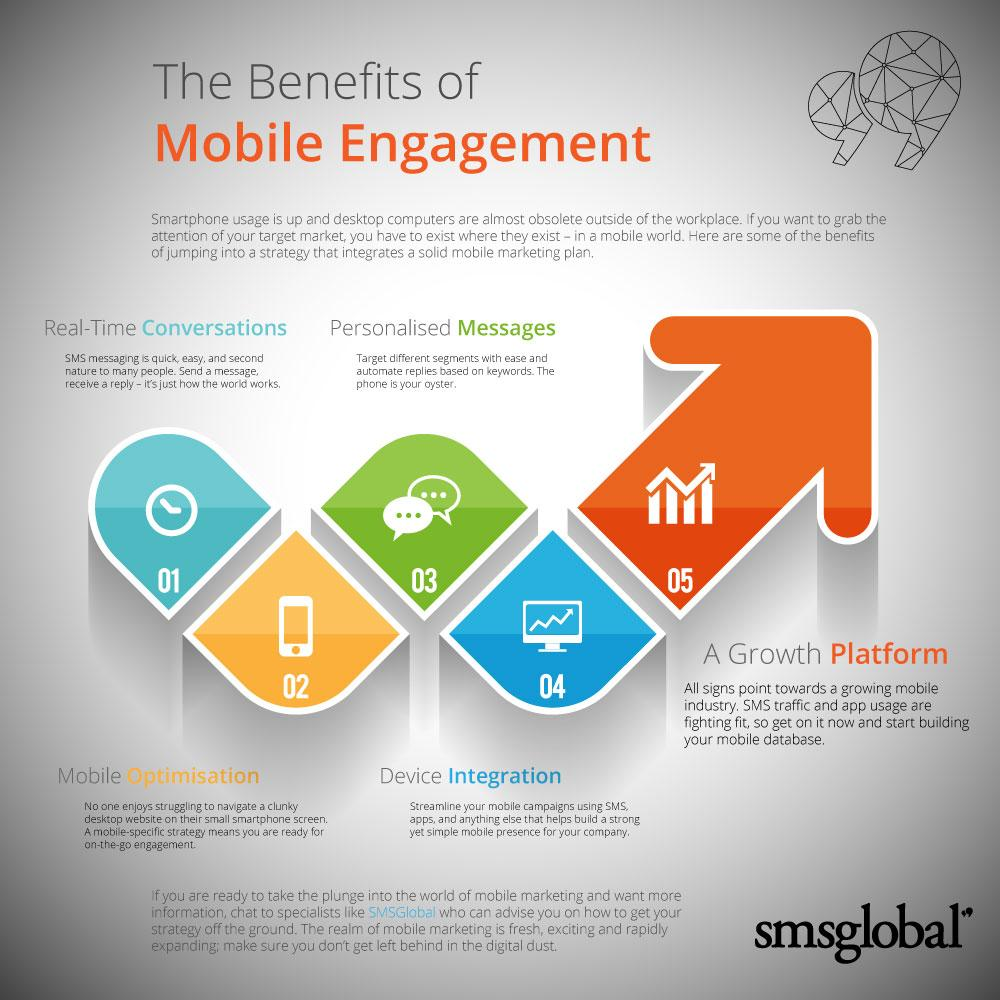Identify some key points in this picture. Mobile device integration is the fourth advantage of mobile engagement, which enables seamless integration between mobile devices and other systems or technologies to enhance overall customer experience. It is predicted that smartphones will replace desktop computers for non-work related activities. Mobile engagement has the benefit of personalized messages, which enhance the overall user experience and help to build stronger connections between brands and their customers. Mobile optimization is the second benefit of mobile engagement. Personalized messages are effective for targeting different segments because they are tailored to the specific needs and preferences of each individual. 